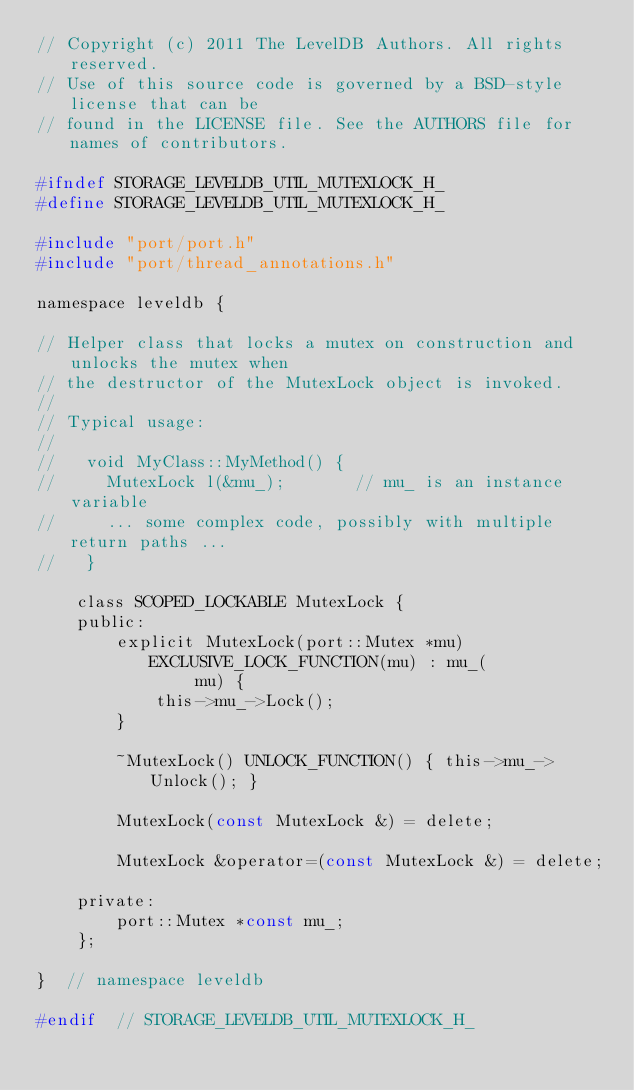Convert code to text. <code><loc_0><loc_0><loc_500><loc_500><_C_>// Copyright (c) 2011 The LevelDB Authors. All rights reserved.
// Use of this source code is governed by a BSD-style license that can be
// found in the LICENSE file. See the AUTHORS file for names of contributors.

#ifndef STORAGE_LEVELDB_UTIL_MUTEXLOCK_H_
#define STORAGE_LEVELDB_UTIL_MUTEXLOCK_H_

#include "port/port.h"
#include "port/thread_annotations.h"

namespace leveldb {

// Helper class that locks a mutex on construction and unlocks the mutex when
// the destructor of the MutexLock object is invoked.
//
// Typical usage:
//
//   void MyClass::MyMethod() {
//     MutexLock l(&mu_);       // mu_ is an instance variable
//     ... some complex code, possibly with multiple return paths ...
//   }

    class SCOPED_LOCKABLE MutexLock {
    public:
        explicit MutexLock(port::Mutex *mu) EXCLUSIVE_LOCK_FUNCTION(mu) : mu_(
                mu) {
            this->mu_->Lock();
        }

        ~MutexLock() UNLOCK_FUNCTION() { this->mu_->Unlock(); }

        MutexLock(const MutexLock &) = delete;

        MutexLock &operator=(const MutexLock &) = delete;

    private:
        port::Mutex *const mu_;
    };

}  // namespace leveldb

#endif  // STORAGE_LEVELDB_UTIL_MUTEXLOCK_H_
</code> 